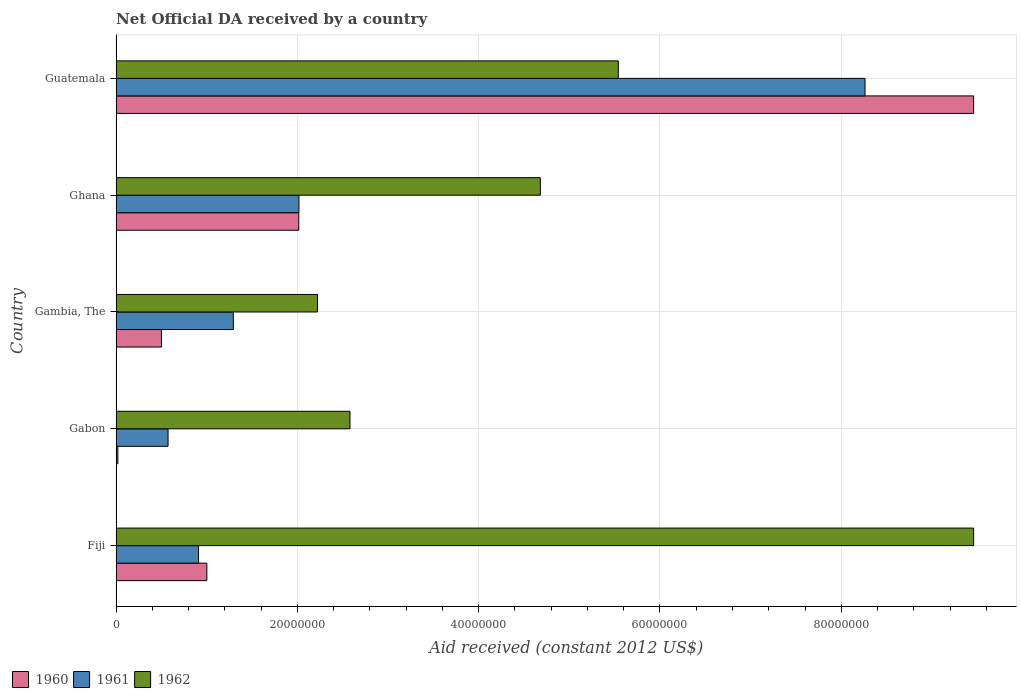How many different coloured bars are there?
Ensure brevity in your answer.  3. How many groups of bars are there?
Your response must be concise. 5. Are the number of bars per tick equal to the number of legend labels?
Provide a succinct answer. Yes. How many bars are there on the 2nd tick from the top?
Offer a terse response. 3. How many bars are there on the 2nd tick from the bottom?
Give a very brief answer. 3. What is the label of the 5th group of bars from the top?
Offer a very short reply. Fiji. What is the net official development assistance aid received in 1962 in Fiji?
Keep it short and to the point. 9.46e+07. Across all countries, what is the maximum net official development assistance aid received in 1961?
Provide a succinct answer. 8.26e+07. In which country was the net official development assistance aid received in 1962 maximum?
Your answer should be compact. Fiji. In which country was the net official development assistance aid received in 1962 minimum?
Provide a succinct answer. Gambia, The. What is the total net official development assistance aid received in 1962 in the graph?
Your answer should be compact. 2.45e+08. What is the difference between the net official development assistance aid received in 1962 in Fiji and that in Gabon?
Your answer should be compact. 6.88e+07. What is the difference between the net official development assistance aid received in 1960 in Ghana and the net official development assistance aid received in 1961 in Gabon?
Make the answer very short. 1.44e+07. What is the average net official development assistance aid received in 1962 per country?
Give a very brief answer. 4.90e+07. What is the difference between the net official development assistance aid received in 1961 and net official development assistance aid received in 1960 in Fiji?
Your answer should be compact. -9.20e+05. In how many countries, is the net official development assistance aid received in 1962 greater than 28000000 US$?
Ensure brevity in your answer.  3. What is the ratio of the net official development assistance aid received in 1962 in Fiji to that in Gambia, The?
Offer a very short reply. 4.26. Is the net official development assistance aid received in 1961 in Gabon less than that in Gambia, The?
Your answer should be very brief. Yes. Is the difference between the net official development assistance aid received in 1961 in Gambia, The and Ghana greater than the difference between the net official development assistance aid received in 1960 in Gambia, The and Ghana?
Offer a very short reply. Yes. What is the difference between the highest and the second highest net official development assistance aid received in 1962?
Give a very brief answer. 3.92e+07. What is the difference between the highest and the lowest net official development assistance aid received in 1961?
Make the answer very short. 7.69e+07. What does the 1st bar from the top in Gambia, The represents?
Ensure brevity in your answer.  1962. Is it the case that in every country, the sum of the net official development assistance aid received in 1960 and net official development assistance aid received in 1961 is greater than the net official development assistance aid received in 1962?
Your answer should be very brief. No. How many bars are there?
Offer a very short reply. 15. Are all the bars in the graph horizontal?
Offer a very short reply. Yes. Are the values on the major ticks of X-axis written in scientific E-notation?
Provide a succinct answer. No. Does the graph contain any zero values?
Your response must be concise. No. How many legend labels are there?
Provide a short and direct response. 3. How are the legend labels stacked?
Your answer should be very brief. Horizontal. What is the title of the graph?
Ensure brevity in your answer.  Net Official DA received by a country. Does "1993" appear as one of the legend labels in the graph?
Offer a very short reply. No. What is the label or title of the X-axis?
Provide a succinct answer. Aid received (constant 2012 US$). What is the Aid received (constant 2012 US$) in 1960 in Fiji?
Provide a short and direct response. 1.00e+07. What is the Aid received (constant 2012 US$) in 1961 in Fiji?
Provide a short and direct response. 9.09e+06. What is the Aid received (constant 2012 US$) in 1962 in Fiji?
Give a very brief answer. 9.46e+07. What is the Aid received (constant 2012 US$) of 1961 in Gabon?
Make the answer very short. 5.73e+06. What is the Aid received (constant 2012 US$) in 1962 in Gabon?
Keep it short and to the point. 2.58e+07. What is the Aid received (constant 2012 US$) in 1960 in Gambia, The?
Ensure brevity in your answer.  5.00e+06. What is the Aid received (constant 2012 US$) of 1961 in Gambia, The?
Your answer should be compact. 1.29e+07. What is the Aid received (constant 2012 US$) of 1962 in Gambia, The?
Your answer should be very brief. 2.22e+07. What is the Aid received (constant 2012 US$) of 1960 in Ghana?
Offer a very short reply. 2.02e+07. What is the Aid received (constant 2012 US$) of 1961 in Ghana?
Your answer should be compact. 2.02e+07. What is the Aid received (constant 2012 US$) in 1962 in Ghana?
Offer a very short reply. 4.68e+07. What is the Aid received (constant 2012 US$) of 1960 in Guatemala?
Ensure brevity in your answer.  9.46e+07. What is the Aid received (constant 2012 US$) of 1961 in Guatemala?
Your answer should be very brief. 8.26e+07. What is the Aid received (constant 2012 US$) of 1962 in Guatemala?
Give a very brief answer. 5.54e+07. Across all countries, what is the maximum Aid received (constant 2012 US$) of 1960?
Ensure brevity in your answer.  9.46e+07. Across all countries, what is the maximum Aid received (constant 2012 US$) of 1961?
Make the answer very short. 8.26e+07. Across all countries, what is the maximum Aid received (constant 2012 US$) in 1962?
Your answer should be compact. 9.46e+07. Across all countries, what is the minimum Aid received (constant 2012 US$) of 1960?
Make the answer very short. 1.90e+05. Across all countries, what is the minimum Aid received (constant 2012 US$) of 1961?
Your response must be concise. 5.73e+06. Across all countries, what is the minimum Aid received (constant 2012 US$) of 1962?
Provide a short and direct response. 2.22e+07. What is the total Aid received (constant 2012 US$) in 1960 in the graph?
Offer a very short reply. 1.30e+08. What is the total Aid received (constant 2012 US$) of 1961 in the graph?
Keep it short and to the point. 1.31e+08. What is the total Aid received (constant 2012 US$) of 1962 in the graph?
Ensure brevity in your answer.  2.45e+08. What is the difference between the Aid received (constant 2012 US$) in 1960 in Fiji and that in Gabon?
Offer a terse response. 9.82e+06. What is the difference between the Aid received (constant 2012 US$) in 1961 in Fiji and that in Gabon?
Your response must be concise. 3.36e+06. What is the difference between the Aid received (constant 2012 US$) of 1962 in Fiji and that in Gabon?
Provide a short and direct response. 6.88e+07. What is the difference between the Aid received (constant 2012 US$) of 1960 in Fiji and that in Gambia, The?
Your response must be concise. 5.01e+06. What is the difference between the Aid received (constant 2012 US$) in 1961 in Fiji and that in Gambia, The?
Offer a terse response. -3.84e+06. What is the difference between the Aid received (constant 2012 US$) in 1962 in Fiji and that in Gambia, The?
Offer a terse response. 7.24e+07. What is the difference between the Aid received (constant 2012 US$) in 1960 in Fiji and that in Ghana?
Keep it short and to the point. -1.01e+07. What is the difference between the Aid received (constant 2012 US$) of 1961 in Fiji and that in Ghana?
Ensure brevity in your answer.  -1.11e+07. What is the difference between the Aid received (constant 2012 US$) in 1962 in Fiji and that in Ghana?
Make the answer very short. 4.78e+07. What is the difference between the Aid received (constant 2012 US$) in 1960 in Fiji and that in Guatemala?
Offer a terse response. -8.46e+07. What is the difference between the Aid received (constant 2012 US$) of 1961 in Fiji and that in Guatemala?
Provide a succinct answer. -7.35e+07. What is the difference between the Aid received (constant 2012 US$) in 1962 in Fiji and that in Guatemala?
Ensure brevity in your answer.  3.92e+07. What is the difference between the Aid received (constant 2012 US$) of 1960 in Gabon and that in Gambia, The?
Offer a terse response. -4.81e+06. What is the difference between the Aid received (constant 2012 US$) in 1961 in Gabon and that in Gambia, The?
Provide a short and direct response. -7.20e+06. What is the difference between the Aid received (constant 2012 US$) of 1962 in Gabon and that in Gambia, The?
Offer a very short reply. 3.58e+06. What is the difference between the Aid received (constant 2012 US$) of 1960 in Gabon and that in Ghana?
Make the answer very short. -2.00e+07. What is the difference between the Aid received (constant 2012 US$) in 1961 in Gabon and that in Ghana?
Provide a succinct answer. -1.44e+07. What is the difference between the Aid received (constant 2012 US$) of 1962 in Gabon and that in Ghana?
Ensure brevity in your answer.  -2.10e+07. What is the difference between the Aid received (constant 2012 US$) in 1960 in Gabon and that in Guatemala?
Your answer should be very brief. -9.44e+07. What is the difference between the Aid received (constant 2012 US$) of 1961 in Gabon and that in Guatemala?
Offer a very short reply. -7.69e+07. What is the difference between the Aid received (constant 2012 US$) in 1962 in Gabon and that in Guatemala?
Give a very brief answer. -2.96e+07. What is the difference between the Aid received (constant 2012 US$) of 1960 in Gambia, The and that in Ghana?
Your response must be concise. -1.52e+07. What is the difference between the Aid received (constant 2012 US$) in 1961 in Gambia, The and that in Ghana?
Keep it short and to the point. -7.24e+06. What is the difference between the Aid received (constant 2012 US$) in 1962 in Gambia, The and that in Ghana?
Offer a very short reply. -2.46e+07. What is the difference between the Aid received (constant 2012 US$) of 1960 in Gambia, The and that in Guatemala?
Your answer should be compact. -8.96e+07. What is the difference between the Aid received (constant 2012 US$) in 1961 in Gambia, The and that in Guatemala?
Offer a terse response. -6.97e+07. What is the difference between the Aid received (constant 2012 US$) of 1962 in Gambia, The and that in Guatemala?
Your answer should be very brief. -3.32e+07. What is the difference between the Aid received (constant 2012 US$) of 1960 in Ghana and that in Guatemala?
Offer a very short reply. -7.44e+07. What is the difference between the Aid received (constant 2012 US$) of 1961 in Ghana and that in Guatemala?
Your answer should be very brief. -6.24e+07. What is the difference between the Aid received (constant 2012 US$) in 1962 in Ghana and that in Guatemala?
Provide a succinct answer. -8.60e+06. What is the difference between the Aid received (constant 2012 US$) of 1960 in Fiji and the Aid received (constant 2012 US$) of 1961 in Gabon?
Offer a terse response. 4.28e+06. What is the difference between the Aid received (constant 2012 US$) of 1960 in Fiji and the Aid received (constant 2012 US$) of 1962 in Gabon?
Make the answer very short. -1.58e+07. What is the difference between the Aid received (constant 2012 US$) in 1961 in Fiji and the Aid received (constant 2012 US$) in 1962 in Gabon?
Your answer should be compact. -1.67e+07. What is the difference between the Aid received (constant 2012 US$) in 1960 in Fiji and the Aid received (constant 2012 US$) in 1961 in Gambia, The?
Give a very brief answer. -2.92e+06. What is the difference between the Aid received (constant 2012 US$) in 1960 in Fiji and the Aid received (constant 2012 US$) in 1962 in Gambia, The?
Keep it short and to the point. -1.22e+07. What is the difference between the Aid received (constant 2012 US$) in 1961 in Fiji and the Aid received (constant 2012 US$) in 1962 in Gambia, The?
Ensure brevity in your answer.  -1.31e+07. What is the difference between the Aid received (constant 2012 US$) of 1960 in Fiji and the Aid received (constant 2012 US$) of 1961 in Ghana?
Give a very brief answer. -1.02e+07. What is the difference between the Aid received (constant 2012 US$) of 1960 in Fiji and the Aid received (constant 2012 US$) of 1962 in Ghana?
Your answer should be compact. -3.68e+07. What is the difference between the Aid received (constant 2012 US$) in 1961 in Fiji and the Aid received (constant 2012 US$) in 1962 in Ghana?
Ensure brevity in your answer.  -3.77e+07. What is the difference between the Aid received (constant 2012 US$) of 1960 in Fiji and the Aid received (constant 2012 US$) of 1961 in Guatemala?
Give a very brief answer. -7.26e+07. What is the difference between the Aid received (constant 2012 US$) in 1960 in Fiji and the Aid received (constant 2012 US$) in 1962 in Guatemala?
Offer a terse response. -4.54e+07. What is the difference between the Aid received (constant 2012 US$) of 1961 in Fiji and the Aid received (constant 2012 US$) of 1962 in Guatemala?
Your answer should be very brief. -4.63e+07. What is the difference between the Aid received (constant 2012 US$) in 1960 in Gabon and the Aid received (constant 2012 US$) in 1961 in Gambia, The?
Your response must be concise. -1.27e+07. What is the difference between the Aid received (constant 2012 US$) in 1960 in Gabon and the Aid received (constant 2012 US$) in 1962 in Gambia, The?
Your answer should be very brief. -2.20e+07. What is the difference between the Aid received (constant 2012 US$) in 1961 in Gabon and the Aid received (constant 2012 US$) in 1962 in Gambia, The?
Your answer should be very brief. -1.65e+07. What is the difference between the Aid received (constant 2012 US$) of 1960 in Gabon and the Aid received (constant 2012 US$) of 1961 in Ghana?
Your answer should be compact. -2.00e+07. What is the difference between the Aid received (constant 2012 US$) of 1960 in Gabon and the Aid received (constant 2012 US$) of 1962 in Ghana?
Your answer should be compact. -4.66e+07. What is the difference between the Aid received (constant 2012 US$) of 1961 in Gabon and the Aid received (constant 2012 US$) of 1962 in Ghana?
Ensure brevity in your answer.  -4.11e+07. What is the difference between the Aid received (constant 2012 US$) in 1960 in Gabon and the Aid received (constant 2012 US$) in 1961 in Guatemala?
Offer a very short reply. -8.24e+07. What is the difference between the Aid received (constant 2012 US$) in 1960 in Gabon and the Aid received (constant 2012 US$) in 1962 in Guatemala?
Your answer should be very brief. -5.52e+07. What is the difference between the Aid received (constant 2012 US$) of 1961 in Gabon and the Aid received (constant 2012 US$) of 1962 in Guatemala?
Provide a succinct answer. -4.97e+07. What is the difference between the Aid received (constant 2012 US$) in 1960 in Gambia, The and the Aid received (constant 2012 US$) in 1961 in Ghana?
Offer a terse response. -1.52e+07. What is the difference between the Aid received (constant 2012 US$) in 1960 in Gambia, The and the Aid received (constant 2012 US$) in 1962 in Ghana?
Make the answer very short. -4.18e+07. What is the difference between the Aid received (constant 2012 US$) in 1961 in Gambia, The and the Aid received (constant 2012 US$) in 1962 in Ghana?
Your response must be concise. -3.39e+07. What is the difference between the Aid received (constant 2012 US$) in 1960 in Gambia, The and the Aid received (constant 2012 US$) in 1961 in Guatemala?
Provide a succinct answer. -7.76e+07. What is the difference between the Aid received (constant 2012 US$) in 1960 in Gambia, The and the Aid received (constant 2012 US$) in 1962 in Guatemala?
Provide a succinct answer. -5.04e+07. What is the difference between the Aid received (constant 2012 US$) in 1961 in Gambia, The and the Aid received (constant 2012 US$) in 1962 in Guatemala?
Ensure brevity in your answer.  -4.25e+07. What is the difference between the Aid received (constant 2012 US$) of 1960 in Ghana and the Aid received (constant 2012 US$) of 1961 in Guatemala?
Provide a succinct answer. -6.25e+07. What is the difference between the Aid received (constant 2012 US$) in 1960 in Ghana and the Aid received (constant 2012 US$) in 1962 in Guatemala?
Provide a short and direct response. -3.52e+07. What is the difference between the Aid received (constant 2012 US$) of 1961 in Ghana and the Aid received (constant 2012 US$) of 1962 in Guatemala?
Your answer should be very brief. -3.52e+07. What is the average Aid received (constant 2012 US$) in 1960 per country?
Provide a short and direct response. 2.60e+07. What is the average Aid received (constant 2012 US$) in 1961 per country?
Your response must be concise. 2.61e+07. What is the average Aid received (constant 2012 US$) in 1962 per country?
Provide a succinct answer. 4.90e+07. What is the difference between the Aid received (constant 2012 US$) in 1960 and Aid received (constant 2012 US$) in 1961 in Fiji?
Your answer should be very brief. 9.20e+05. What is the difference between the Aid received (constant 2012 US$) in 1960 and Aid received (constant 2012 US$) in 1962 in Fiji?
Provide a short and direct response. -8.46e+07. What is the difference between the Aid received (constant 2012 US$) of 1961 and Aid received (constant 2012 US$) of 1962 in Fiji?
Your answer should be very brief. -8.55e+07. What is the difference between the Aid received (constant 2012 US$) of 1960 and Aid received (constant 2012 US$) of 1961 in Gabon?
Provide a succinct answer. -5.54e+06. What is the difference between the Aid received (constant 2012 US$) in 1960 and Aid received (constant 2012 US$) in 1962 in Gabon?
Ensure brevity in your answer.  -2.56e+07. What is the difference between the Aid received (constant 2012 US$) in 1961 and Aid received (constant 2012 US$) in 1962 in Gabon?
Your answer should be very brief. -2.01e+07. What is the difference between the Aid received (constant 2012 US$) in 1960 and Aid received (constant 2012 US$) in 1961 in Gambia, The?
Make the answer very short. -7.93e+06. What is the difference between the Aid received (constant 2012 US$) of 1960 and Aid received (constant 2012 US$) of 1962 in Gambia, The?
Offer a very short reply. -1.72e+07. What is the difference between the Aid received (constant 2012 US$) in 1961 and Aid received (constant 2012 US$) in 1962 in Gambia, The?
Your answer should be very brief. -9.29e+06. What is the difference between the Aid received (constant 2012 US$) of 1960 and Aid received (constant 2012 US$) of 1962 in Ghana?
Ensure brevity in your answer.  -2.66e+07. What is the difference between the Aid received (constant 2012 US$) in 1961 and Aid received (constant 2012 US$) in 1962 in Ghana?
Make the answer very short. -2.66e+07. What is the difference between the Aid received (constant 2012 US$) of 1960 and Aid received (constant 2012 US$) of 1961 in Guatemala?
Offer a very short reply. 1.20e+07. What is the difference between the Aid received (constant 2012 US$) of 1960 and Aid received (constant 2012 US$) of 1962 in Guatemala?
Your answer should be compact. 3.92e+07. What is the difference between the Aid received (constant 2012 US$) in 1961 and Aid received (constant 2012 US$) in 1962 in Guatemala?
Ensure brevity in your answer.  2.72e+07. What is the ratio of the Aid received (constant 2012 US$) in 1960 in Fiji to that in Gabon?
Provide a short and direct response. 52.68. What is the ratio of the Aid received (constant 2012 US$) in 1961 in Fiji to that in Gabon?
Your answer should be compact. 1.59. What is the ratio of the Aid received (constant 2012 US$) of 1962 in Fiji to that in Gabon?
Offer a very short reply. 3.67. What is the ratio of the Aid received (constant 2012 US$) in 1960 in Fiji to that in Gambia, The?
Ensure brevity in your answer.  2. What is the ratio of the Aid received (constant 2012 US$) of 1961 in Fiji to that in Gambia, The?
Ensure brevity in your answer.  0.7. What is the ratio of the Aid received (constant 2012 US$) in 1962 in Fiji to that in Gambia, The?
Make the answer very short. 4.26. What is the ratio of the Aid received (constant 2012 US$) of 1960 in Fiji to that in Ghana?
Offer a terse response. 0.5. What is the ratio of the Aid received (constant 2012 US$) of 1961 in Fiji to that in Ghana?
Your answer should be very brief. 0.45. What is the ratio of the Aid received (constant 2012 US$) of 1962 in Fiji to that in Ghana?
Ensure brevity in your answer.  2.02. What is the ratio of the Aid received (constant 2012 US$) in 1960 in Fiji to that in Guatemala?
Ensure brevity in your answer.  0.11. What is the ratio of the Aid received (constant 2012 US$) in 1961 in Fiji to that in Guatemala?
Offer a terse response. 0.11. What is the ratio of the Aid received (constant 2012 US$) in 1962 in Fiji to that in Guatemala?
Offer a terse response. 1.71. What is the ratio of the Aid received (constant 2012 US$) of 1960 in Gabon to that in Gambia, The?
Offer a terse response. 0.04. What is the ratio of the Aid received (constant 2012 US$) of 1961 in Gabon to that in Gambia, The?
Provide a short and direct response. 0.44. What is the ratio of the Aid received (constant 2012 US$) of 1962 in Gabon to that in Gambia, The?
Offer a very short reply. 1.16. What is the ratio of the Aid received (constant 2012 US$) in 1960 in Gabon to that in Ghana?
Make the answer very short. 0.01. What is the ratio of the Aid received (constant 2012 US$) of 1961 in Gabon to that in Ghana?
Offer a terse response. 0.28. What is the ratio of the Aid received (constant 2012 US$) in 1962 in Gabon to that in Ghana?
Give a very brief answer. 0.55. What is the ratio of the Aid received (constant 2012 US$) in 1960 in Gabon to that in Guatemala?
Offer a very short reply. 0. What is the ratio of the Aid received (constant 2012 US$) of 1961 in Gabon to that in Guatemala?
Provide a succinct answer. 0.07. What is the ratio of the Aid received (constant 2012 US$) in 1962 in Gabon to that in Guatemala?
Your answer should be compact. 0.47. What is the ratio of the Aid received (constant 2012 US$) in 1960 in Gambia, The to that in Ghana?
Keep it short and to the point. 0.25. What is the ratio of the Aid received (constant 2012 US$) of 1961 in Gambia, The to that in Ghana?
Keep it short and to the point. 0.64. What is the ratio of the Aid received (constant 2012 US$) in 1962 in Gambia, The to that in Ghana?
Your response must be concise. 0.47. What is the ratio of the Aid received (constant 2012 US$) in 1960 in Gambia, The to that in Guatemala?
Offer a terse response. 0.05. What is the ratio of the Aid received (constant 2012 US$) in 1961 in Gambia, The to that in Guatemala?
Keep it short and to the point. 0.16. What is the ratio of the Aid received (constant 2012 US$) in 1962 in Gambia, The to that in Guatemala?
Make the answer very short. 0.4. What is the ratio of the Aid received (constant 2012 US$) in 1960 in Ghana to that in Guatemala?
Your response must be concise. 0.21. What is the ratio of the Aid received (constant 2012 US$) in 1961 in Ghana to that in Guatemala?
Keep it short and to the point. 0.24. What is the ratio of the Aid received (constant 2012 US$) in 1962 in Ghana to that in Guatemala?
Offer a very short reply. 0.84. What is the difference between the highest and the second highest Aid received (constant 2012 US$) in 1960?
Ensure brevity in your answer.  7.44e+07. What is the difference between the highest and the second highest Aid received (constant 2012 US$) of 1961?
Provide a short and direct response. 6.24e+07. What is the difference between the highest and the second highest Aid received (constant 2012 US$) of 1962?
Keep it short and to the point. 3.92e+07. What is the difference between the highest and the lowest Aid received (constant 2012 US$) in 1960?
Your answer should be compact. 9.44e+07. What is the difference between the highest and the lowest Aid received (constant 2012 US$) in 1961?
Ensure brevity in your answer.  7.69e+07. What is the difference between the highest and the lowest Aid received (constant 2012 US$) of 1962?
Offer a terse response. 7.24e+07. 